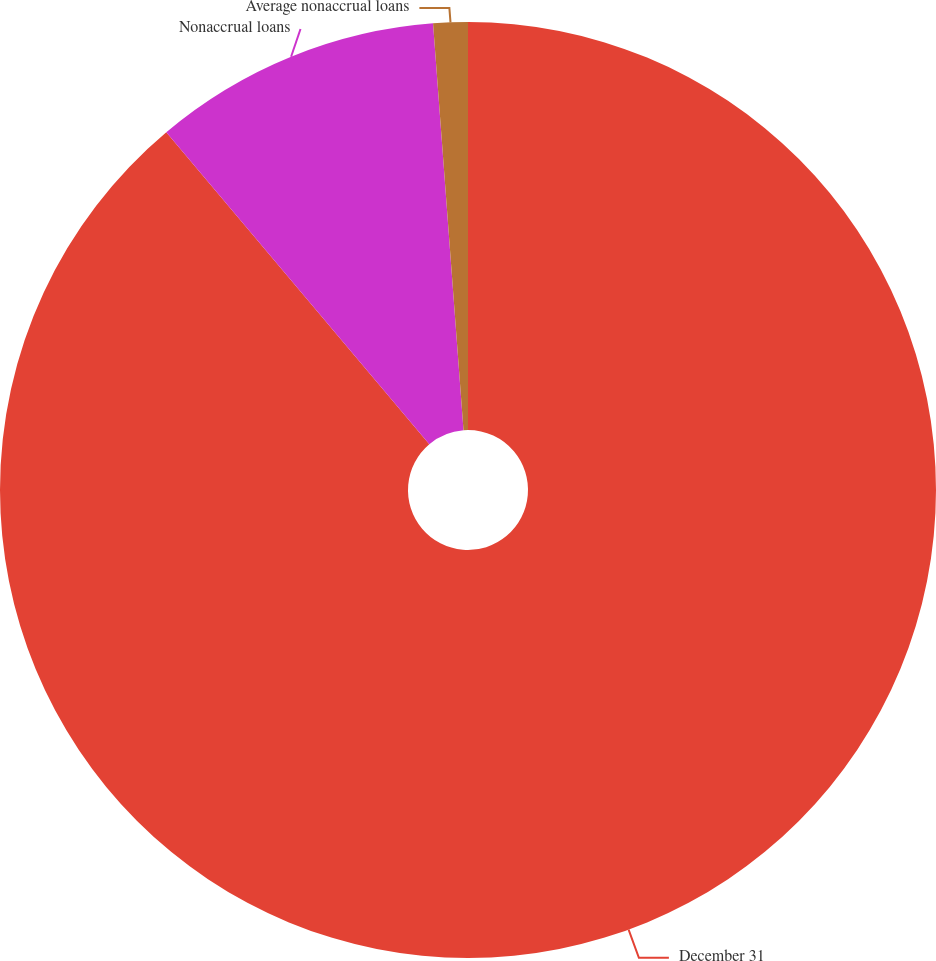Convert chart. <chart><loc_0><loc_0><loc_500><loc_500><pie_chart><fcel>December 31<fcel>Nonaccrual loans<fcel>Average nonaccrual loans<nl><fcel>88.85%<fcel>9.96%<fcel>1.19%<nl></chart> 